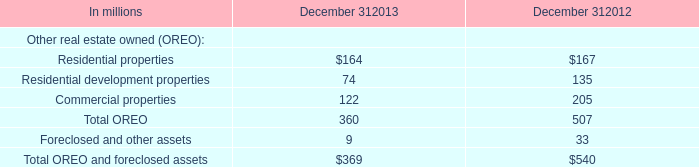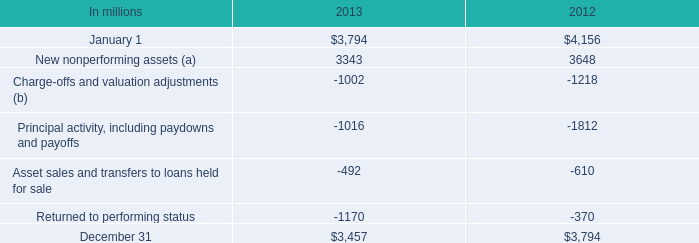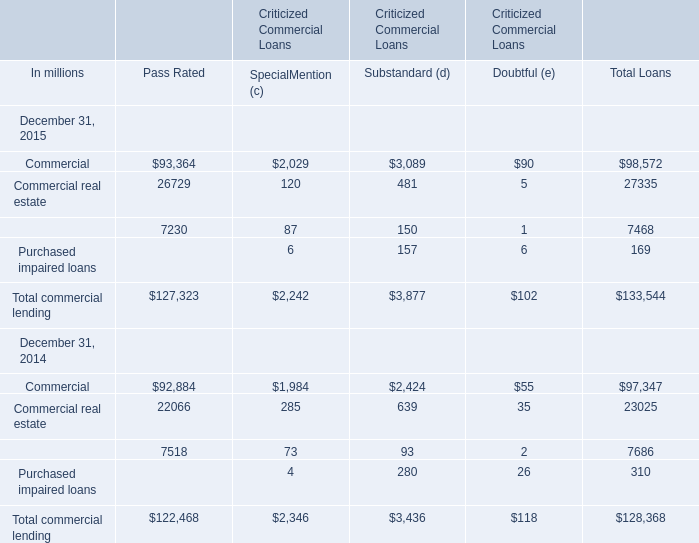How many commercial lending exceed the average of total commercial lending in 2015 for total loans? 
Computations: (133544 / 4)
Answer: 33386.0. 